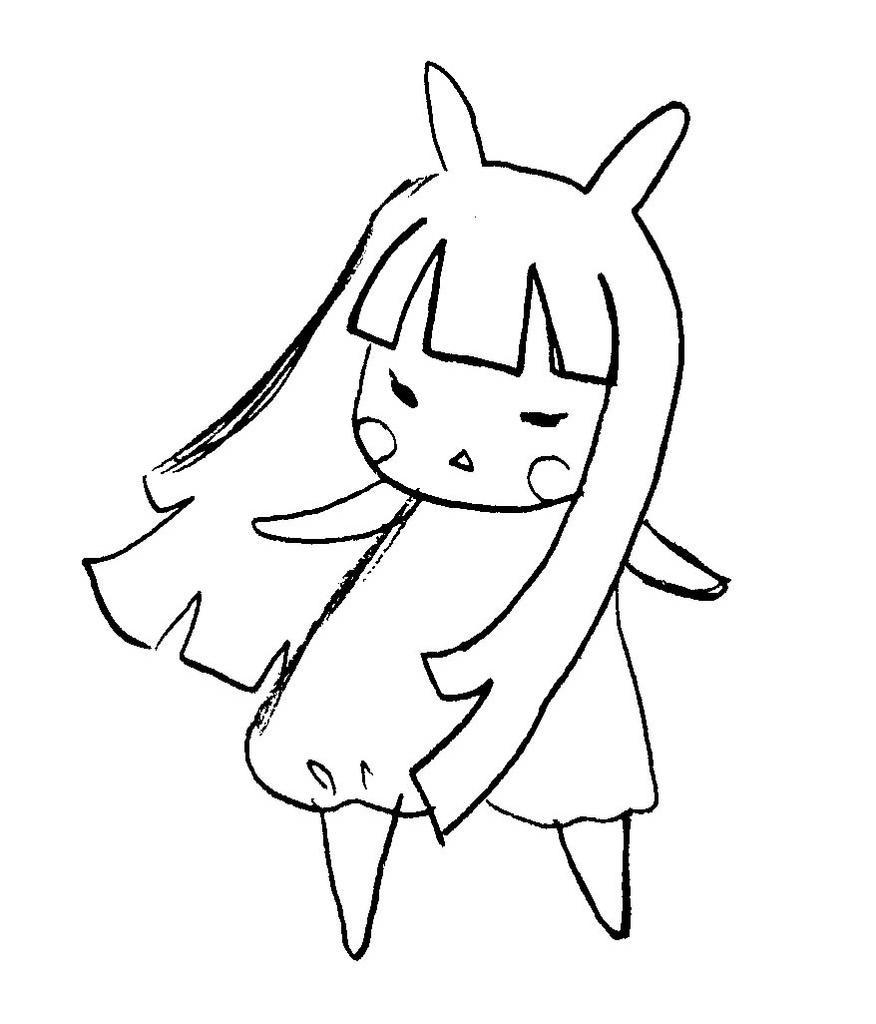How would you summarize this image in a sentence or two? In this picture, we see the line art of the girl or the doll. In the background, it is white in color. 